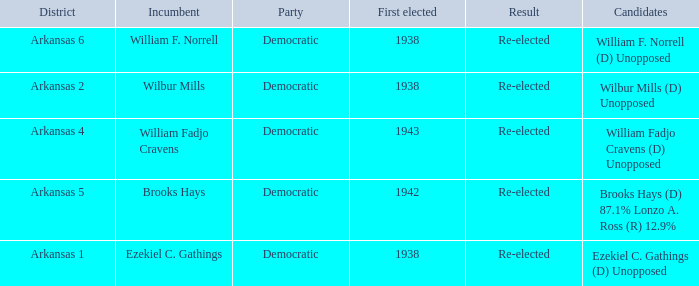What party did incumbent Brooks Hays belong to?  Democratic. 